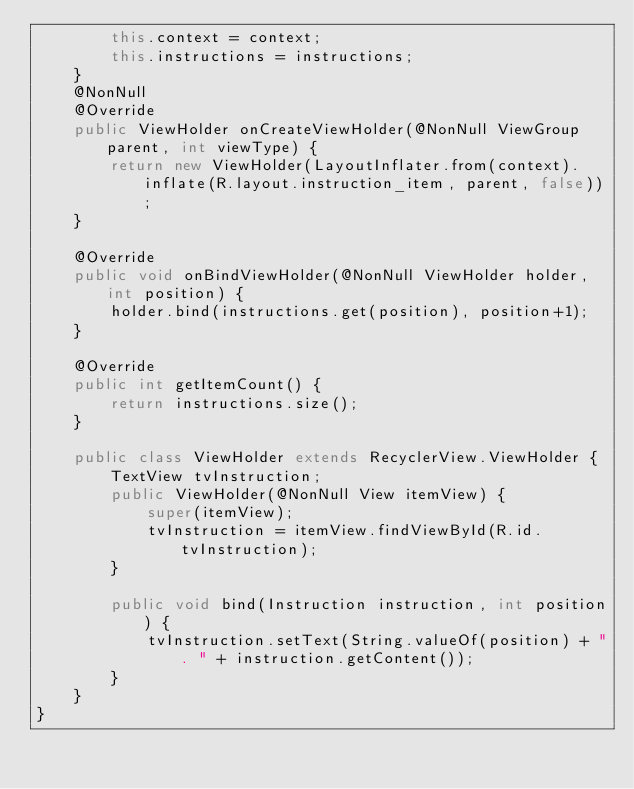Convert code to text. <code><loc_0><loc_0><loc_500><loc_500><_Java_>        this.context = context;
        this.instructions = instructions;
    }
    @NonNull
    @Override
    public ViewHolder onCreateViewHolder(@NonNull ViewGroup parent, int viewType) {
        return new ViewHolder(LayoutInflater.from(context).inflate(R.layout.instruction_item, parent, false));
    }

    @Override
    public void onBindViewHolder(@NonNull ViewHolder holder, int position) {
        holder.bind(instructions.get(position), position+1);
    }

    @Override
    public int getItemCount() {
        return instructions.size();
    }

    public class ViewHolder extends RecyclerView.ViewHolder {
        TextView tvInstruction;
        public ViewHolder(@NonNull View itemView) {
            super(itemView);
            tvInstruction = itemView.findViewById(R.id.tvInstruction);
        }

        public void bind(Instruction instruction, int position) {
            tvInstruction.setText(String.valueOf(position) + ". " + instruction.getContent());
        }
    }
}
</code> 